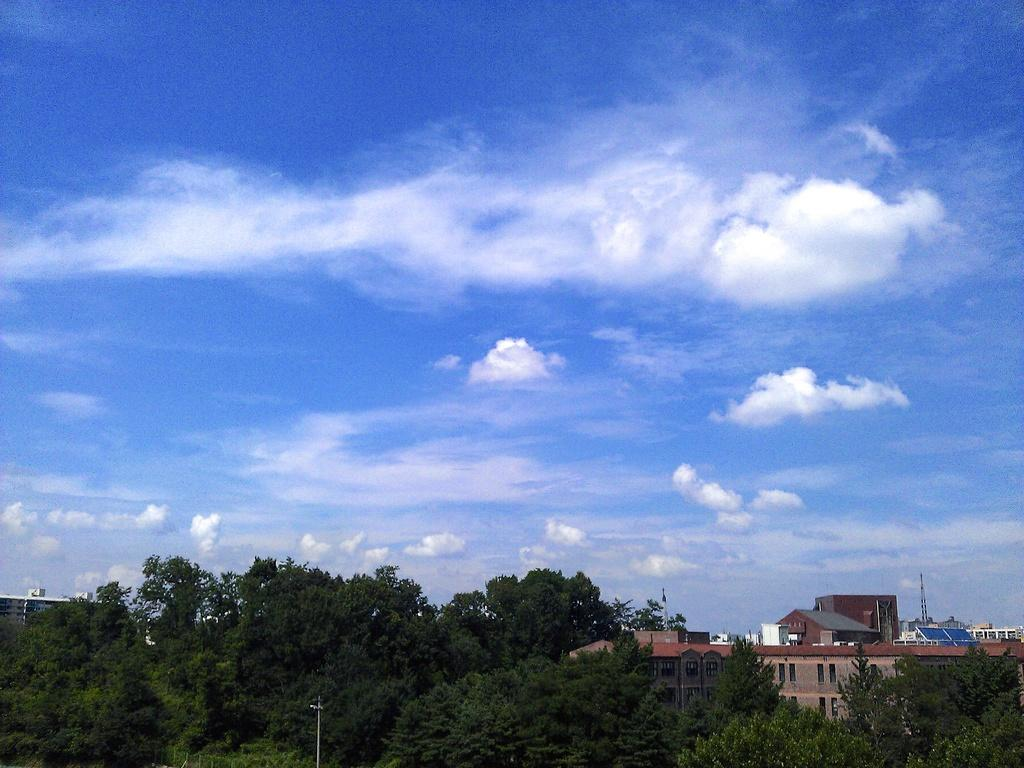What type of natural elements can be seen in the image? There are trees in the image. What man-made structures are present in the image? There are poles and buildings in the image. What can be seen in the background of the image? The sky is visible in the background of the image. What type of quilt is draped over the trees in the image? There is no quilt present in the image; it features trees, poles, buildings, and the sky. What frame is holding the buildings in place in the image? There is no frame holding the buildings in place in the image; they are standing on their own. 